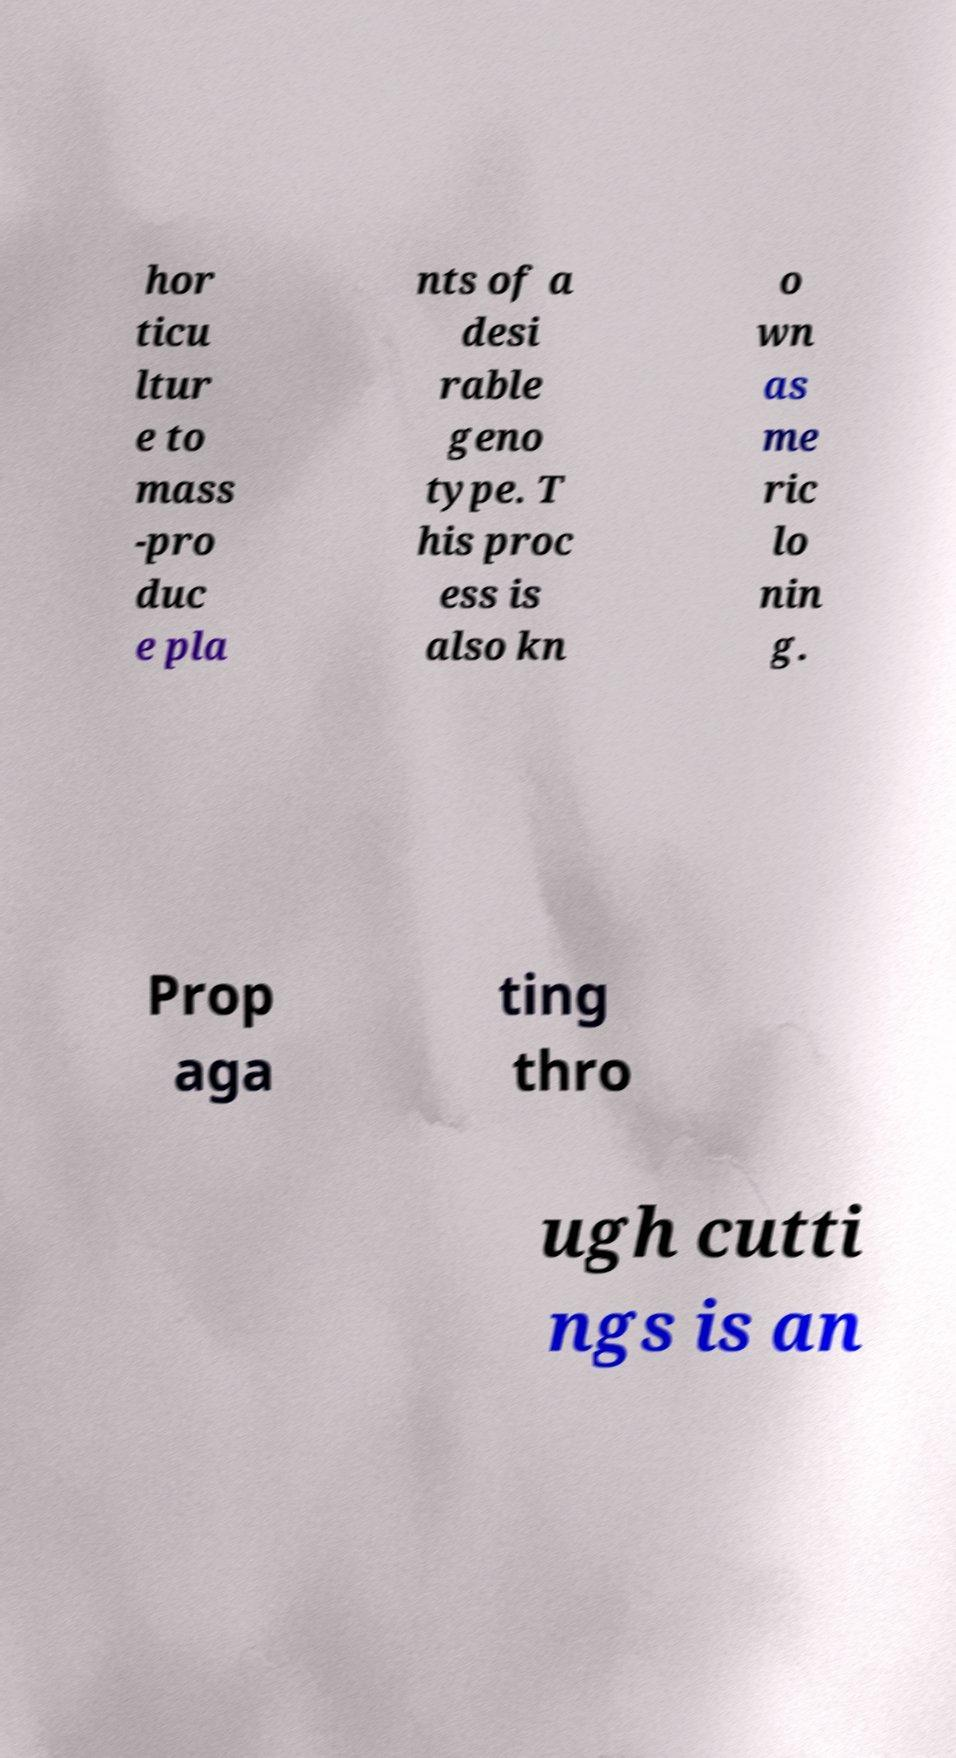I need the written content from this picture converted into text. Can you do that? hor ticu ltur e to mass -pro duc e pla nts of a desi rable geno type. T his proc ess is also kn o wn as me ric lo nin g. Prop aga ting thro ugh cutti ngs is an 